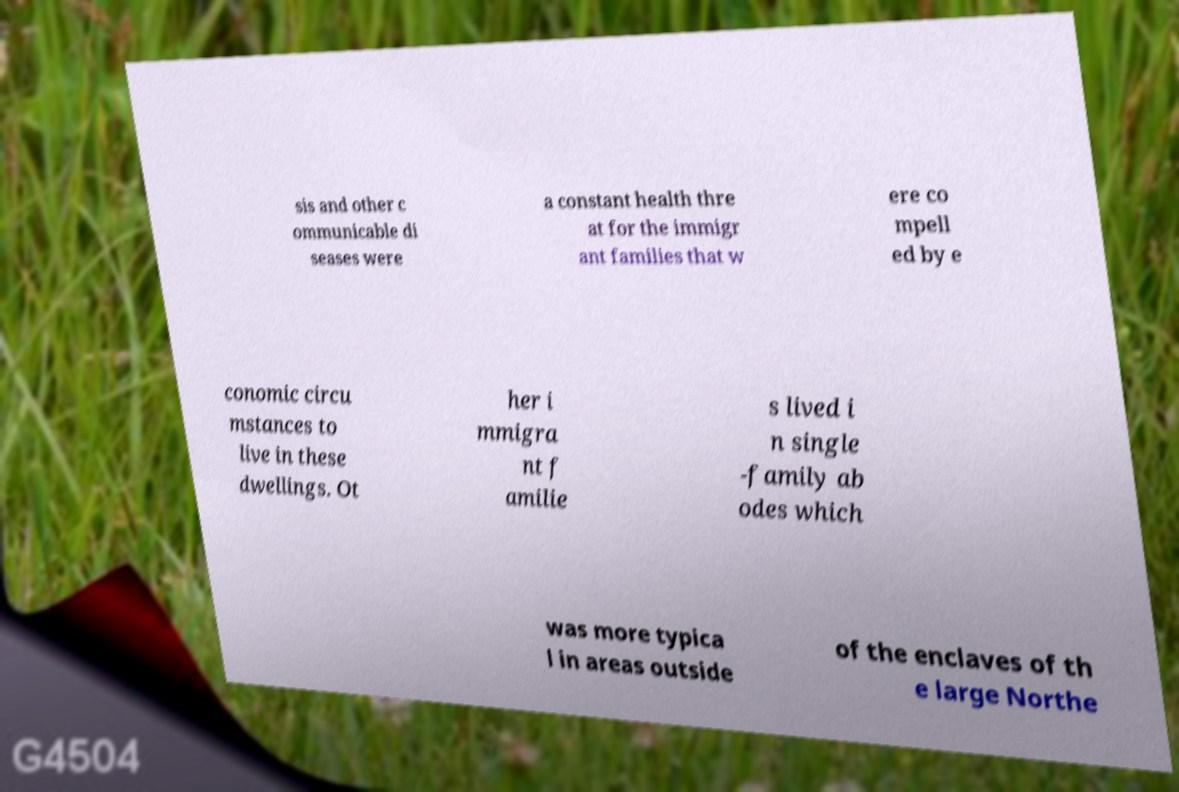For documentation purposes, I need the text within this image transcribed. Could you provide that? sis and other c ommunicable di seases were a constant health thre at for the immigr ant families that w ere co mpell ed by e conomic circu mstances to live in these dwellings. Ot her i mmigra nt f amilie s lived i n single -family ab odes which was more typica l in areas outside of the enclaves of th e large Northe 